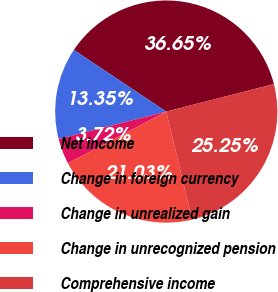Convert chart. <chart><loc_0><loc_0><loc_500><loc_500><pie_chart><fcel>Net income<fcel>Change in foreign currency<fcel>Change in unrealized gain<fcel>Change in unrecognized pension<fcel>Comprehensive income<nl><fcel>36.65%<fcel>13.35%<fcel>3.72%<fcel>21.03%<fcel>25.25%<nl></chart> 